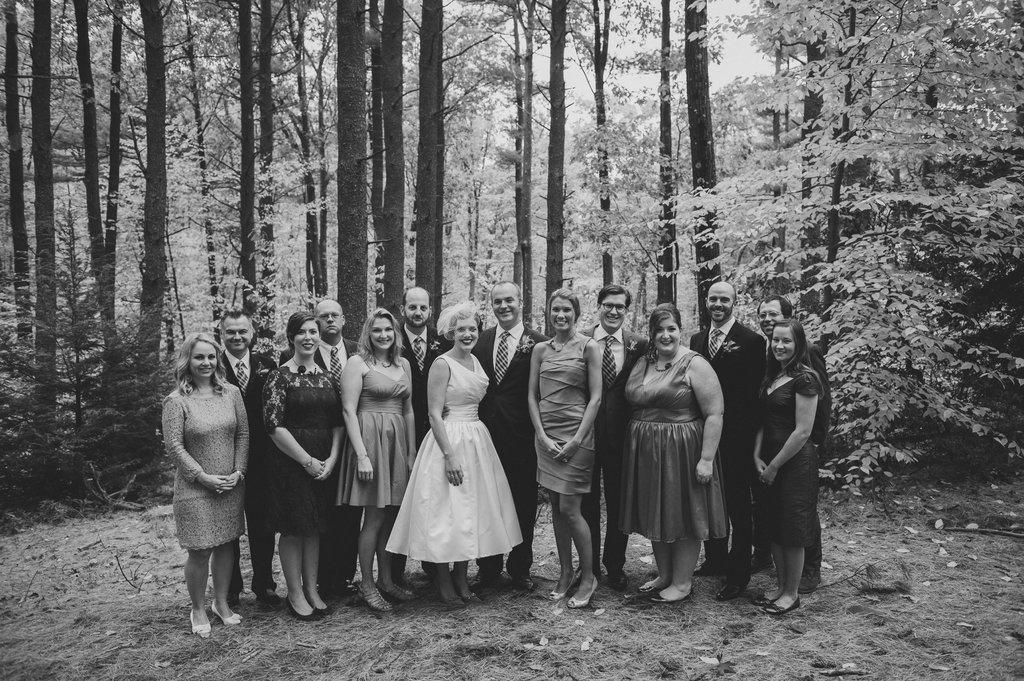Could you give a brief overview of what you see in this image? It is a black and white image. In this picture, we can see a group of people are standing on the ground and watching. Here we can see few people are smiling. Background there are so many trees. 